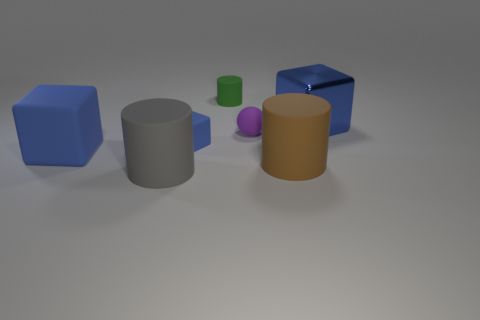What number of other objects are there of the same shape as the shiny thing?
Offer a very short reply. 2. How many things are blue cubes that are on the right side of the small green cylinder or large cubes on the left side of the tiny green rubber thing?
Make the answer very short. 2. How many other things are the same color as the metallic object?
Offer a very short reply. 2. Is the number of cubes that are on the left side of the blue metallic block less than the number of cylinders behind the gray rubber cylinder?
Keep it short and to the point. No. What number of cyan rubber things are there?
Your response must be concise. 0. Is there anything else that has the same material as the gray object?
Provide a succinct answer. Yes. There is a tiny blue thing that is the same shape as the large blue metallic thing; what material is it?
Give a very brief answer. Rubber. Is the number of gray things that are in front of the gray rubber cylinder less than the number of gray matte cylinders?
Ensure brevity in your answer.  Yes. There is a big blue object that is left of the green rubber object; is it the same shape as the tiny blue object?
Offer a terse response. Yes. Is there any other thing of the same color as the large metallic cube?
Provide a succinct answer. Yes. 